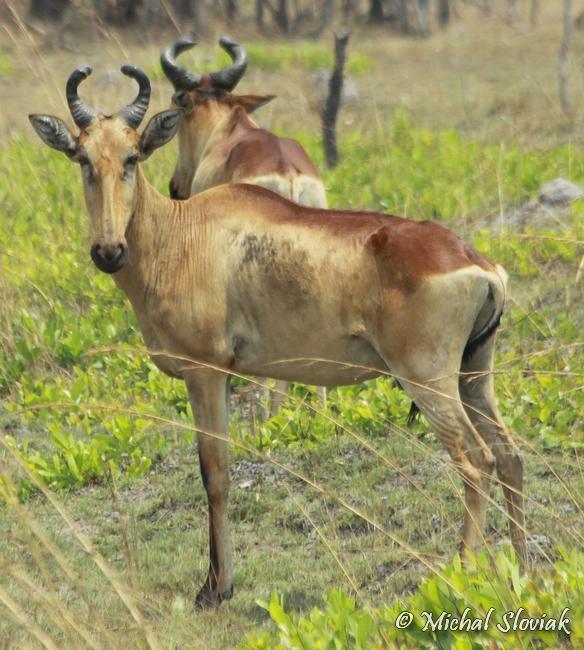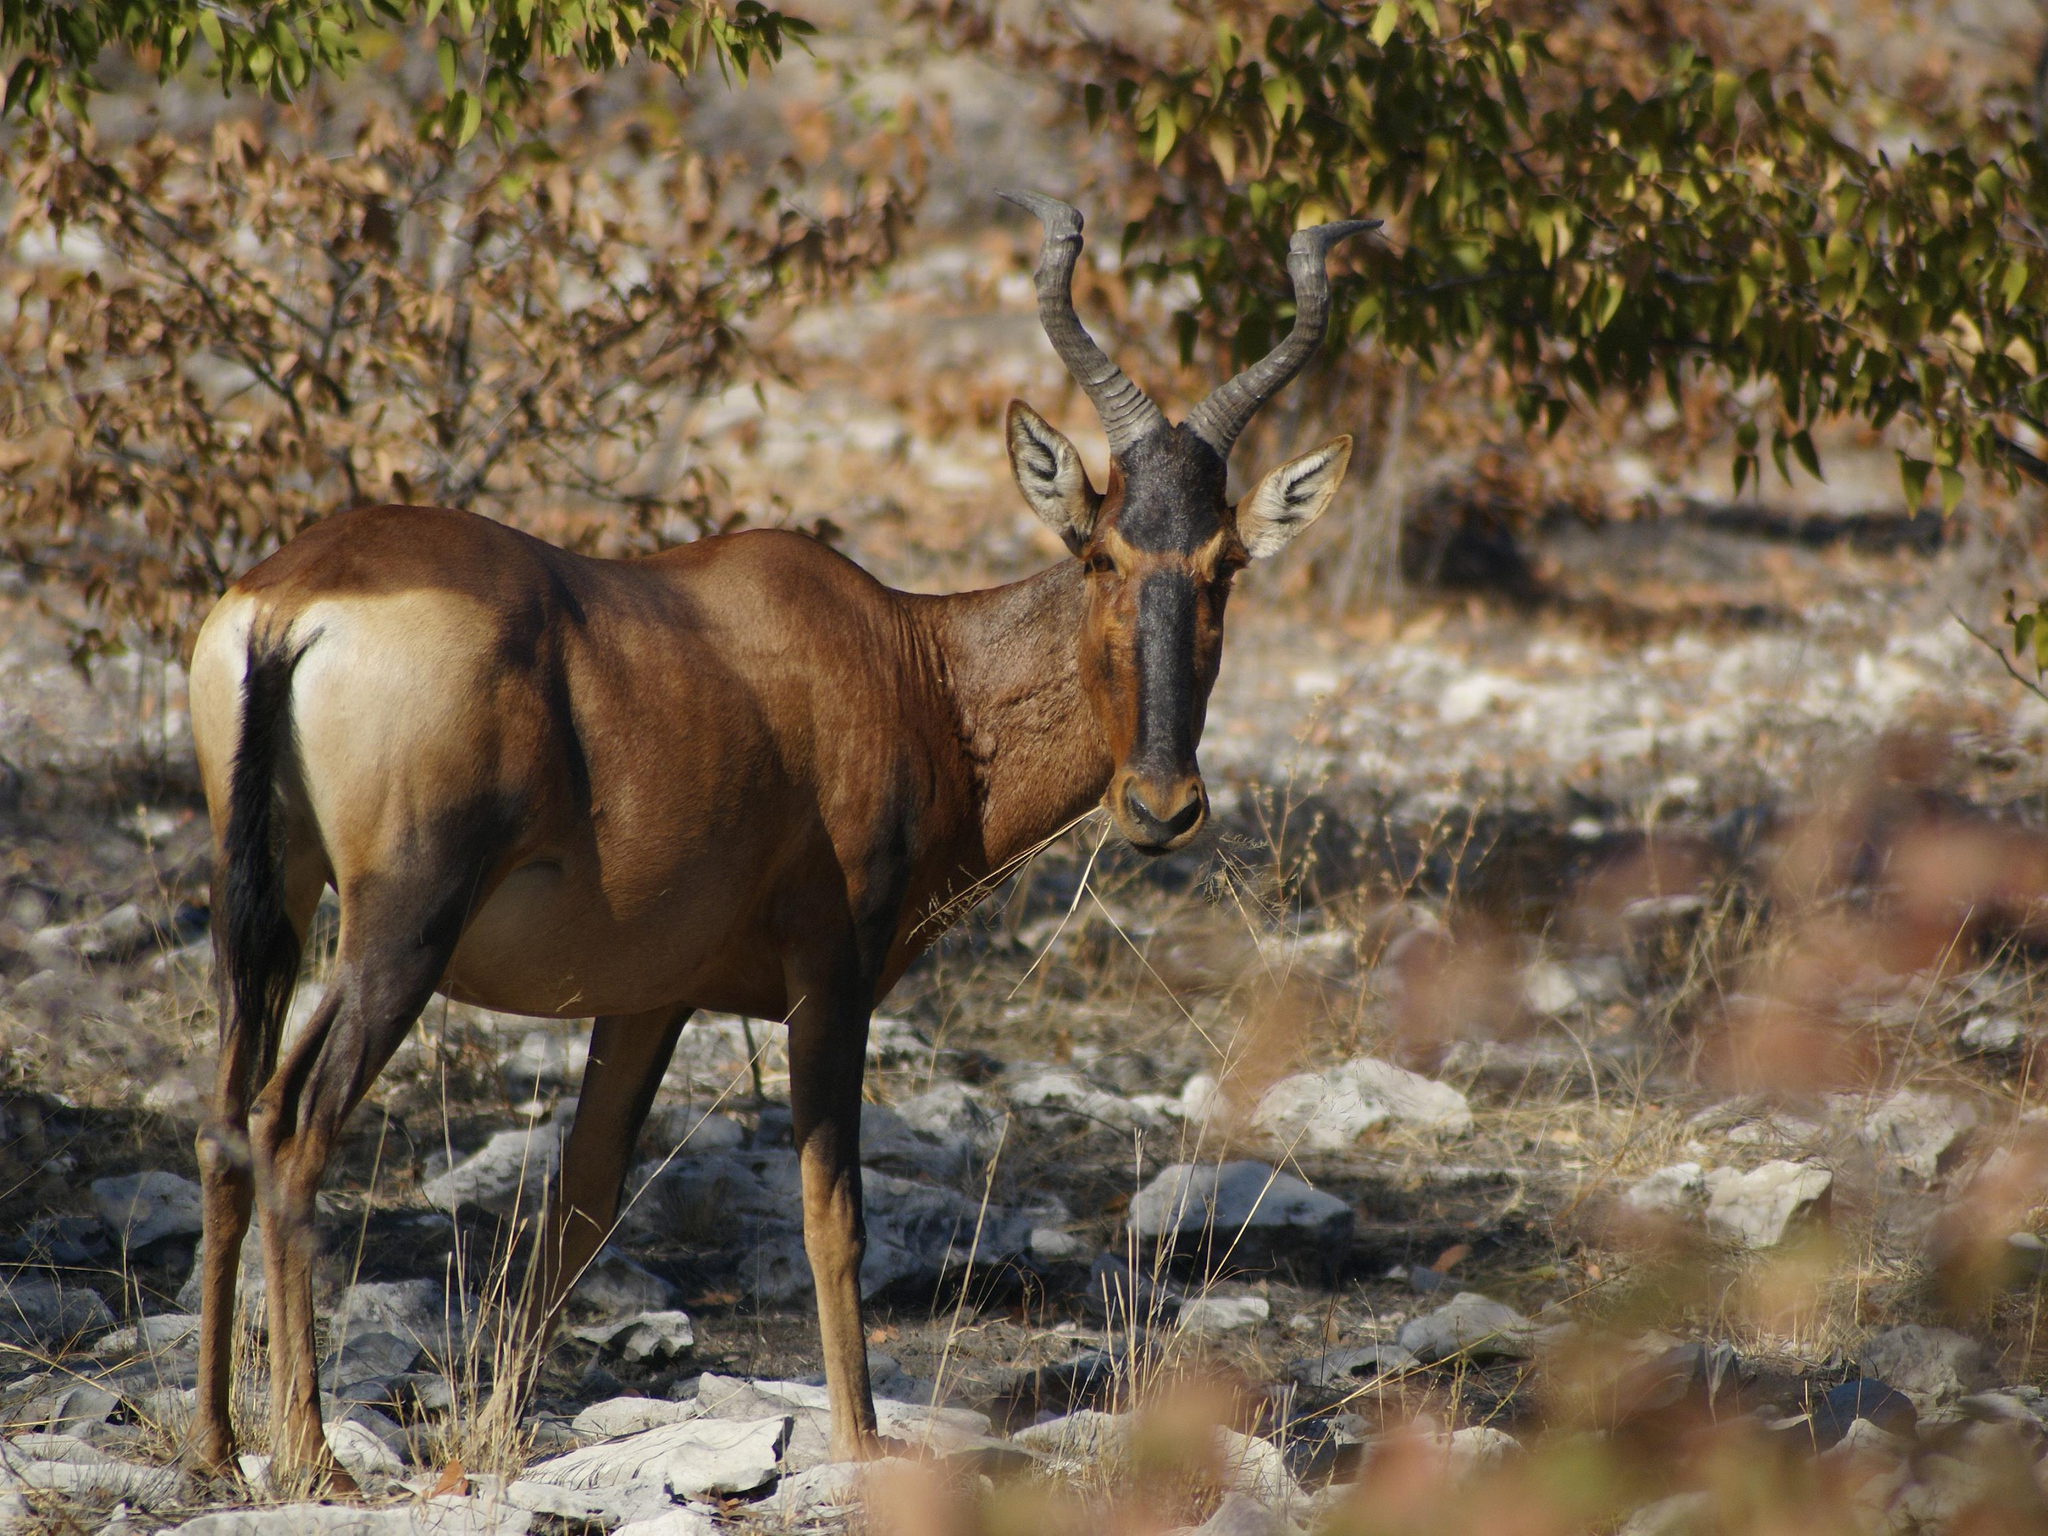The first image is the image on the left, the second image is the image on the right. Examine the images to the left and right. Is the description "In one image, a mammal figure is behind a horned animal." accurate? Answer yes or no. Yes. 